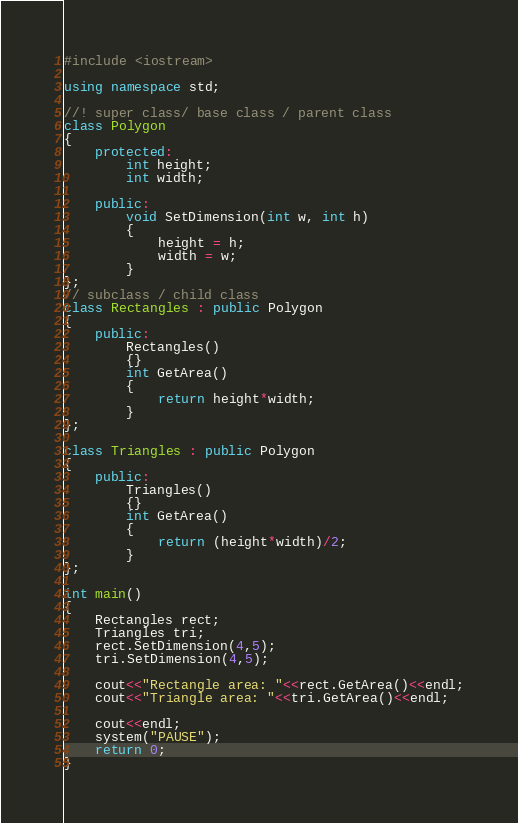<code> <loc_0><loc_0><loc_500><loc_500><_C++_>#include <iostream>

using namespace std;

//! super class/ base class / parent class
class Polygon
{
	protected:
		int height;
		int width;
		
	public:
		void SetDimension(int w, int h)
		{
			height = h;
			width = w;
		}
};
// subclass / child class
class Rectangles : public Polygon
{	
	public:
		Rectangles()
		{}
		int GetArea()
		{
			return height*width;
		}	
};

class Triangles : public Polygon
{
	public:
		Triangles()
		{}
		int GetArea()
		{
			return (height*width)/2;
		}
};

int main()
{
	Rectangles rect;
	Triangles tri;
	rect.SetDimension(4,5);
	tri.SetDimension(4,5);
	
	cout<<"Rectangle area: "<<rect.GetArea()<<endl;
	cout<<"Triangle area: "<<tri.GetArea()<<endl;
	
	cout<<endl;
	system("PAUSE");
	return 0;
}
</code> 